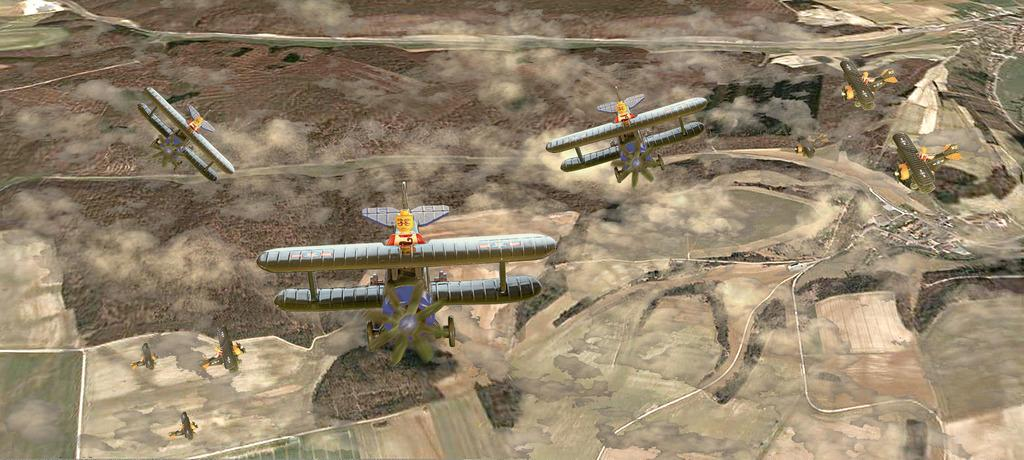What perspective is the image taken from? The image is taken from a top view. What can be seen in the image from this perspective? There are multiple airplanes in the image. What is visible at the bottom of the image? There is land visible at the bottom of the image. What type of vegetation can be seen in the image? There are trees in the image. How many oranges are being copied by the duck in the image? There are no oranges or ducks present in the image. 